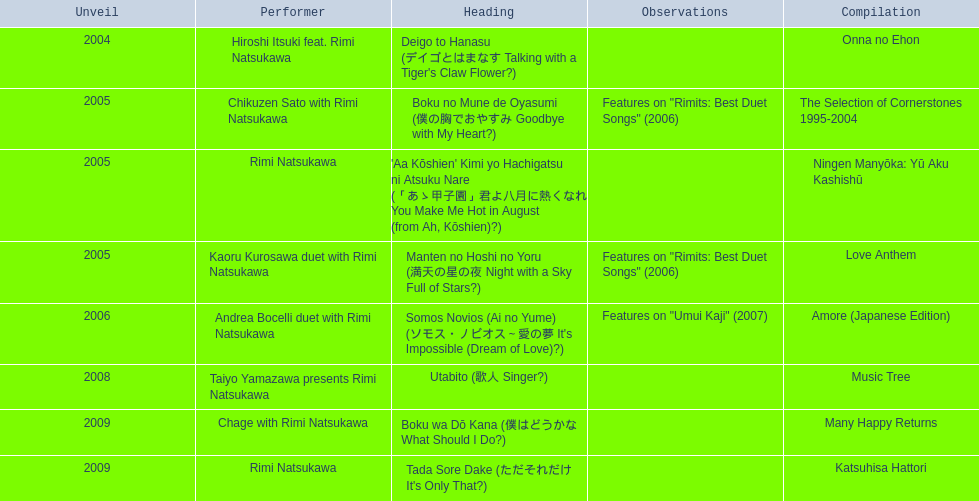What are all of the titles? Deigo to Hanasu (デイゴとはまなす Talking with a Tiger's Claw Flower?), Boku no Mune de Oyasumi (僕の胸でおやすみ Goodbye with My Heart?), 'Aa Kōshien' Kimi yo Hachigatsu ni Atsuku Nare (「あゝ甲子園」君よ八月に熱くなれ You Make Me Hot in August (from Ah, Kōshien)?), Manten no Hoshi no Yoru (満天の星の夜 Night with a Sky Full of Stars?), Somos Novios (Ai no Yume) (ソモス・ノビオス～愛の夢 It's Impossible (Dream of Love)?), Utabito (歌人 Singer?), Boku wa Dō Kana (僕はどうかな What Should I Do?), Tada Sore Dake (ただそれだけ It's Only That?). What are their notes? , Features on "Rimits: Best Duet Songs" (2006), , Features on "Rimits: Best Duet Songs" (2006), Features on "Umui Kaji" (2007), , , . Which title shares its notes with manten no hoshi no yoru (man tian noxing noye night with a sky full of stars?)? Boku no Mune de Oyasumi (僕の胸でおやすみ Goodbye with My Heart?). 